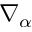Convert formula to latex. <formula><loc_0><loc_0><loc_500><loc_500>\nabla _ { \alpha }</formula> 